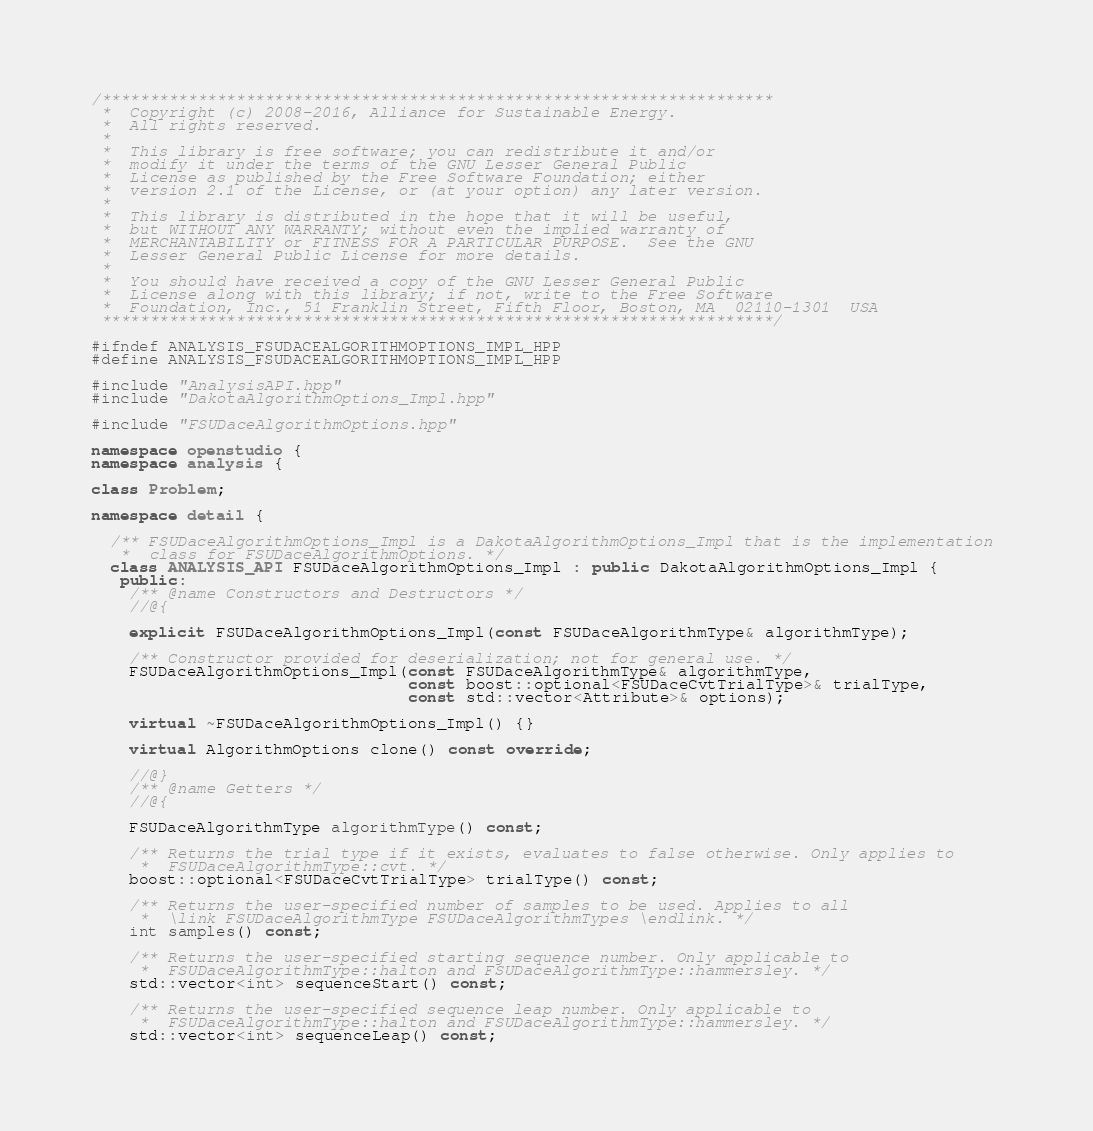<code> <loc_0><loc_0><loc_500><loc_500><_C++_>/**********************************************************************
 *  Copyright (c) 2008-2016, Alliance for Sustainable Energy.
 *  All rights reserved.
 *
 *  This library is free software; you can redistribute it and/or
 *  modify it under the terms of the GNU Lesser General Public
 *  License as published by the Free Software Foundation; either
 *  version 2.1 of the License, or (at your option) any later version.
 *
 *  This library is distributed in the hope that it will be useful,
 *  but WITHOUT ANY WARRANTY; without even the implied warranty of
 *  MERCHANTABILITY or FITNESS FOR A PARTICULAR PURPOSE.  See the GNU
 *  Lesser General Public License for more details.
 *
 *  You should have received a copy of the GNU Lesser General Public
 *  License along with this library; if not, write to the Free Software
 *  Foundation, Inc., 51 Franklin Street, Fifth Floor, Boston, MA  02110-1301  USA
 **********************************************************************/

#ifndef ANALYSIS_FSUDACEALGORITHMOPTIONS_IMPL_HPP
#define ANALYSIS_FSUDACEALGORITHMOPTIONS_IMPL_HPP

#include "AnalysisAPI.hpp"
#include "DakotaAlgorithmOptions_Impl.hpp"

#include "FSUDaceAlgorithmOptions.hpp"

namespace openstudio {
namespace analysis {

class Problem;

namespace detail {

  /** FSUDaceAlgorithmOptions_Impl is a DakotaAlgorithmOptions_Impl that is the implementation 
   *  class for FSUDaceAlgorithmOptions. */ 
  class ANALYSIS_API FSUDaceAlgorithmOptions_Impl : public DakotaAlgorithmOptions_Impl {
   public:
    /** @name Constructors and Destructors */
    //@{

    explicit FSUDaceAlgorithmOptions_Impl(const FSUDaceAlgorithmType& algorithmType);

    /** Constructor provided for deserialization; not for general use. */
    FSUDaceAlgorithmOptions_Impl(const FSUDaceAlgorithmType& algorithmType,
                                 const boost::optional<FSUDaceCvtTrialType>& trialType,
                                 const std::vector<Attribute>& options);

    virtual ~FSUDaceAlgorithmOptions_Impl() {}

    virtual AlgorithmOptions clone() const override;

    //@}
    /** @name Getters */
    //@{

    FSUDaceAlgorithmType algorithmType() const;

    /** Returns the trial type if it exists, evaluates to false otherwise. Only applies to
     *  FSUDaceAlgorithmType::cvt. */
    boost::optional<FSUDaceCvtTrialType> trialType() const;

    /** Returns the user-specified number of samples to be used. Applies to all
     *  \link FSUDaceAlgorithmType FSUDaceAlgorithmTypes \endlink. */
    int samples() const;

    /** Returns the user-specified starting sequence number. Only applicable to 
     *  FSUDaceAlgorithmType::halton and FSUDaceAlgorithmType::hammersley. */
    std::vector<int> sequenceStart() const;

    /** Returns the user-specified sequence leap number. Only applicable to 
     *  FSUDaceAlgorithmType::halton and FSUDaceAlgorithmType::hammersley. */
    std::vector<int> sequenceLeap() const;
</code> 